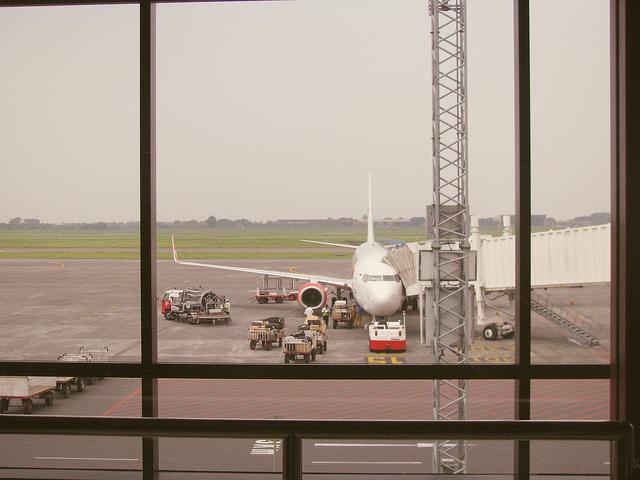What does the worker ride up in?
Quick response, please. Truck. What side of the plane would people load on?
Answer briefly. Right. What has the plane been written?
Write a very short answer. Nothing. What time is it?
Concise answer only. Afternoon. Is this a color photo?
Concise answer only. Yes. What does the sky look like in these scene?
Keep it brief. Cloudy. Which parking space pictured is empty?
Answer briefly. Left. What color is the plains trail in the background?
Be succinct. White. Is there glass in the window frame?
Keep it brief. Yes. Where could this picture be taken from?
Be succinct. Airport. What is this a group of?
Quick response, please. Trucks. How many planes are there?
Write a very short answer. 1. 